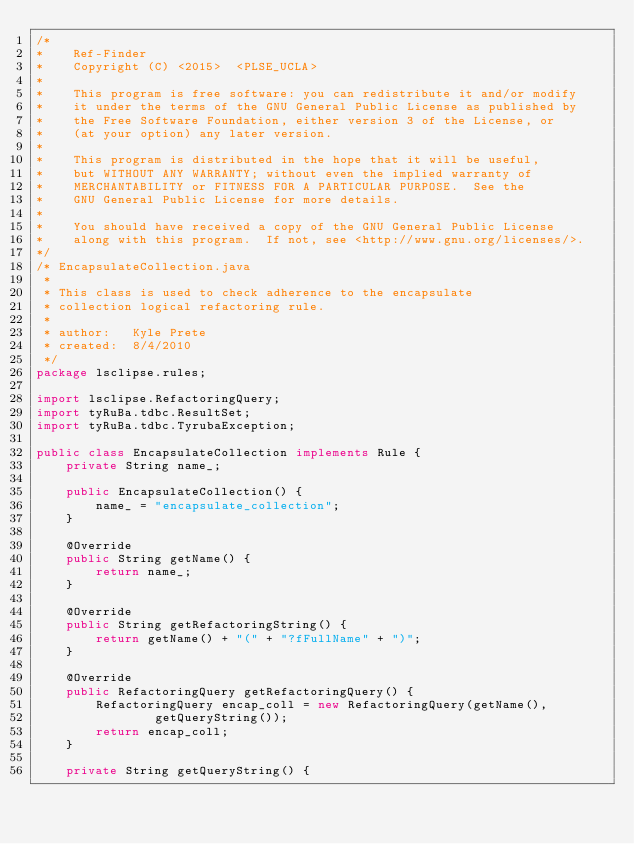<code> <loc_0><loc_0><loc_500><loc_500><_Java_>/* 
*    Ref-Finder
*    Copyright (C) <2015>  <PLSE_UCLA>
*
*    This program is free software: you can redistribute it and/or modify
*    it under the terms of the GNU General Public License as published by
*    the Free Software Foundation, either version 3 of the License, or
*    (at your option) any later version.
*
*    This program is distributed in the hope that it will be useful,
*    but WITHOUT ANY WARRANTY; without even the implied warranty of
*    MERCHANTABILITY or FITNESS FOR A PARTICULAR PURPOSE.  See the
*    GNU General Public License for more details.
*
*    You should have received a copy of the GNU General Public License
*    along with this program.  If not, see <http://www.gnu.org/licenses/>.
*/
/* EncapsulateCollection.java
 * 
 * This class is used to check adherence to the encapsulate
 * collection logical refactoring rule.
 * 
 * author:   Kyle Prete
 * created:  8/4/2010
 */
package lsclipse.rules;

import lsclipse.RefactoringQuery;
import tyRuBa.tdbc.ResultSet;
import tyRuBa.tdbc.TyrubaException;

public class EncapsulateCollection implements Rule {
	private String name_;

	public EncapsulateCollection() {
		name_ = "encapsulate_collection";
	}

	@Override
	public String getName() {
		return name_;
	}

	@Override
	public String getRefactoringString() {
		return getName() + "(" + "?fFullName" + ")";
	}

	@Override
	public RefactoringQuery getRefactoringQuery() {
		RefactoringQuery encap_coll = new RefactoringQuery(getName(),
				getQueryString());
		return encap_coll;
	}

	private String getQueryString() {</code> 